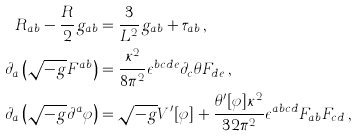<formula> <loc_0><loc_0><loc_500><loc_500>R _ { a b } - \frac { R } { 2 } g _ { a b } & = \frac { 3 } { L ^ { 2 } } g _ { a b } + \tau _ { a b } \, , \\ \partial _ { a } \left ( \sqrt { - g } F ^ { a b } \right ) & = \frac { \kappa ^ { 2 } } { 8 \pi ^ { 2 } } \epsilon ^ { b c d e } \partial _ { c } \theta F _ { d e } \, , \\ \partial _ { a } \left ( \sqrt { - g } \partial ^ { a } \varphi \right ) & = { \sqrt { - g } } V ^ { \prime } [ \varphi ] + \frac { \theta ^ { \prime } [ \varphi ] \kappa ^ { 2 } } { 3 2 \pi ^ { 2 } } \epsilon ^ { a b c d } F _ { a b } F _ { c d } \, ,</formula> 